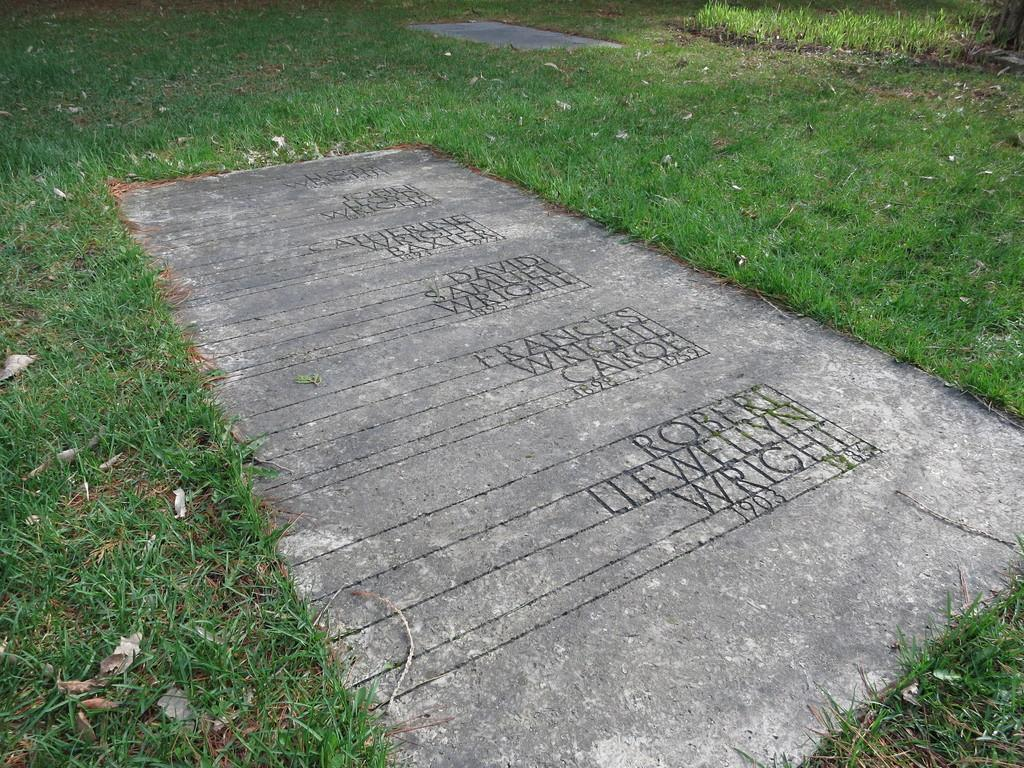What is the main object in the image? There is a stone in the image. What is written on the stone? There is text written on the stone. What can be seen in the background of the image? There is grass visible in the background of the image. Where are the secretary and the toys located in the image? There is no secretary or toys present in the image; it only features a stone with text and grass in the background. 